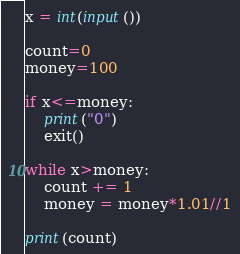Convert code to text. <code><loc_0><loc_0><loc_500><loc_500><_Python_>x = int(input())

count=0
money=100

if x<=money:
    print("0")
    exit()

while x>money:
    count += 1
    money = money*1.01//1

print(count)</code> 